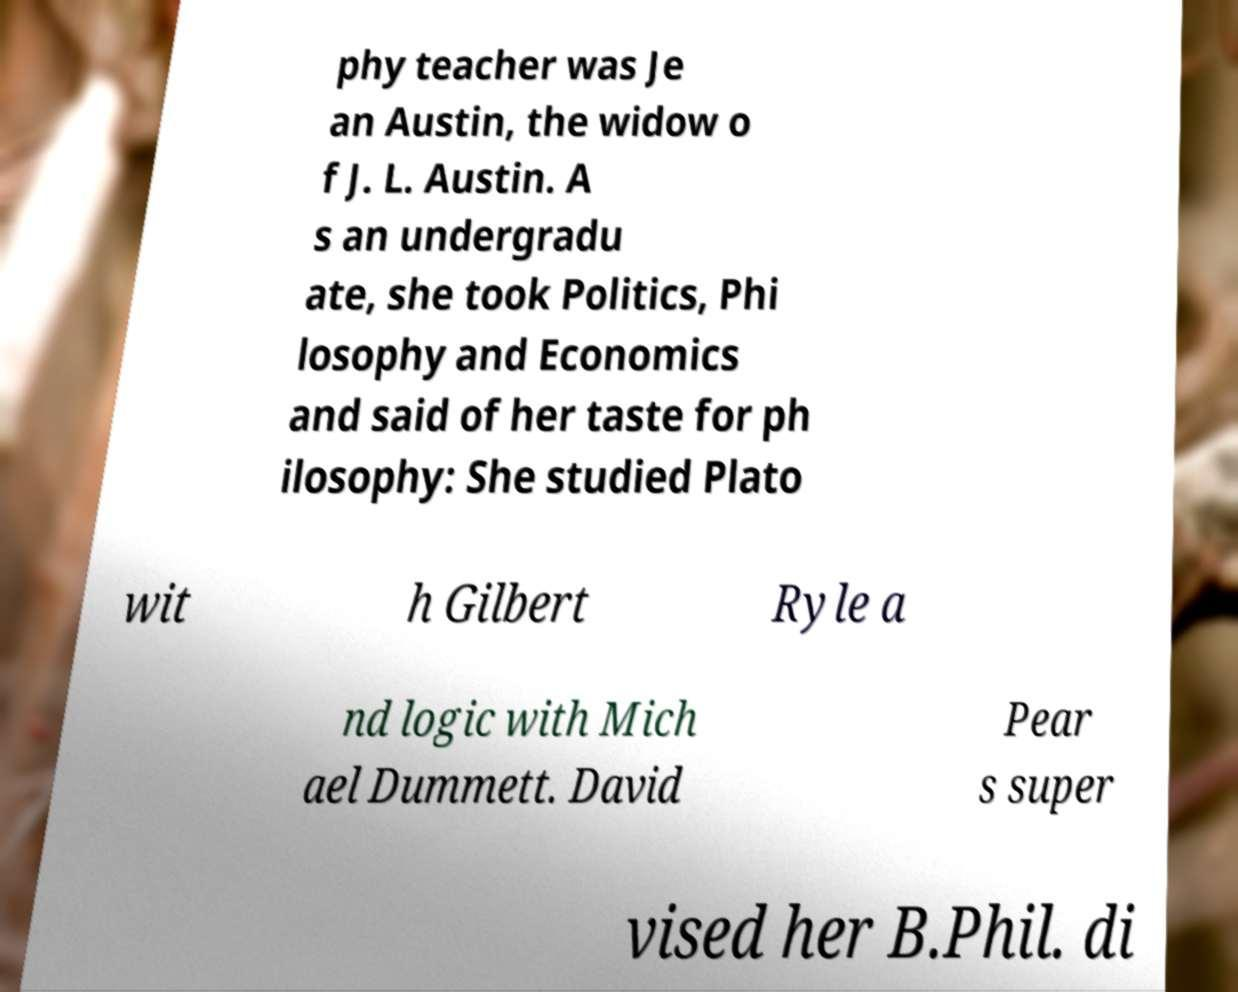Please read and relay the text visible in this image. What does it say? phy teacher was Je an Austin, the widow o f J. L. Austin. A s an undergradu ate, she took Politics, Phi losophy and Economics and said of her taste for ph ilosophy: She studied Plato wit h Gilbert Ryle a nd logic with Mich ael Dummett. David Pear s super vised her B.Phil. di 